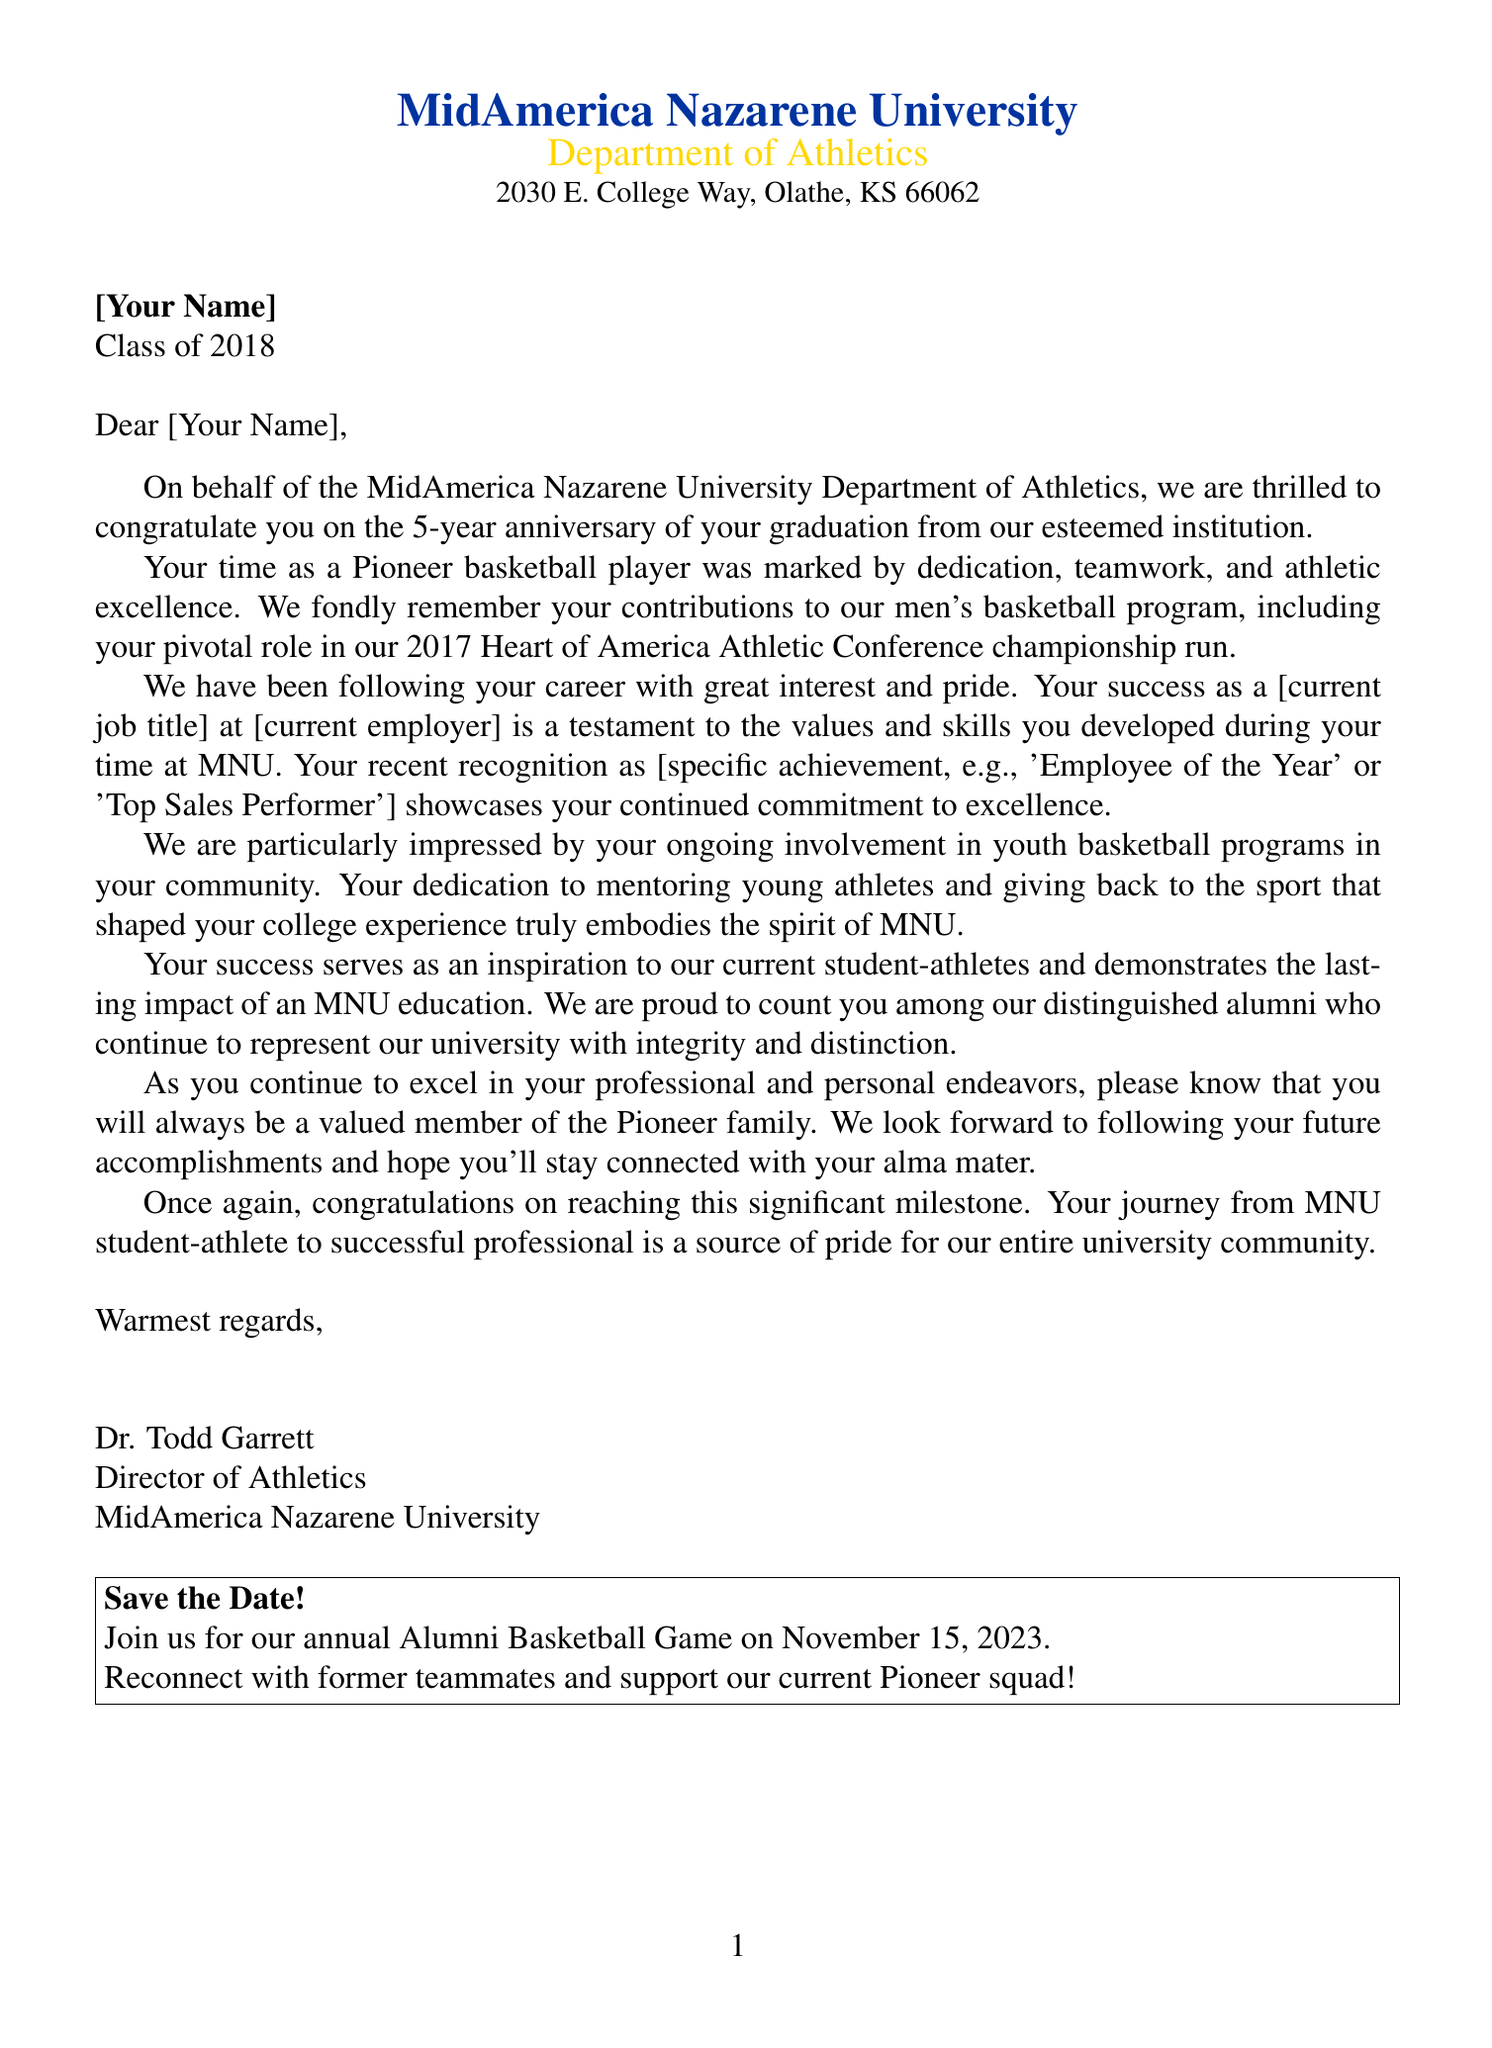What is the name of the university? The university's name is stated in the letter header.
Answer: MidAmerica Nazarene University Who is the letter addressed to? The recipient's name is specified in the document.
Answer: [Your Name] What year did you graduate? The graduation year is indicated in the recipient's information.
Answer: 2018 What championship run is mentioned? The document mentions a specific achievement in the body paragraph regarding your college career.
Answer: 2017 Heart of America Athletic Conference championship run What is the date of the upcoming event? The date of the Alumni Basketball Game is clearly stated in the additional info section.
Answer: November 15, 2023 Who signed the letter? The signatory's name is provided at the end of the document.
Answer: Dr. Todd Garrett What is the current title of the recipient? The document mentions the recipient's job title in the context of their career achievements.
Answer: [current job title] What type of achievement is highlighted in post-graduation accomplishments? The document notes a specific accolade to showcase the recipient's success.
Answer: [specific achievement, e.g., 'Employee of the Year'] What is the closing line of the letter? The closing line is mentioned at the end of the letter preceding the signatory.
Answer: Warmest regards 